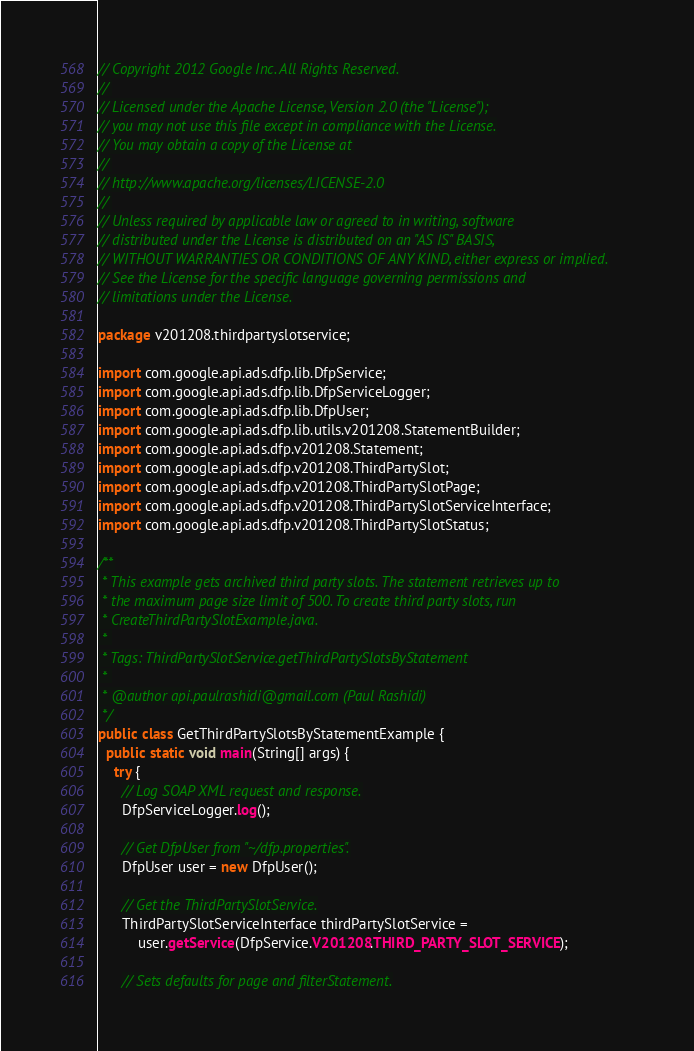<code> <loc_0><loc_0><loc_500><loc_500><_Java_>// Copyright 2012 Google Inc. All Rights Reserved.
//
// Licensed under the Apache License, Version 2.0 (the "License");
// you may not use this file except in compliance with the License.
// You may obtain a copy of the License at
//
// http://www.apache.org/licenses/LICENSE-2.0
//
// Unless required by applicable law or agreed to in writing, software
// distributed under the License is distributed on an "AS IS" BASIS,
// WITHOUT WARRANTIES OR CONDITIONS OF ANY KIND, either express or implied.
// See the License for the specific language governing permissions and
// limitations under the License.

package v201208.thirdpartyslotservice;

import com.google.api.ads.dfp.lib.DfpService;
import com.google.api.ads.dfp.lib.DfpServiceLogger;
import com.google.api.ads.dfp.lib.DfpUser;
import com.google.api.ads.dfp.lib.utils.v201208.StatementBuilder;
import com.google.api.ads.dfp.v201208.Statement;
import com.google.api.ads.dfp.v201208.ThirdPartySlot;
import com.google.api.ads.dfp.v201208.ThirdPartySlotPage;
import com.google.api.ads.dfp.v201208.ThirdPartySlotServiceInterface;
import com.google.api.ads.dfp.v201208.ThirdPartySlotStatus;

/**
 * This example gets archived third party slots. The statement retrieves up to
 * the maximum page size limit of 500. To create third party slots, run
 * CreateThirdPartySlotExample.java.
 * 
 * Tags: ThirdPartySlotService.getThirdPartySlotsByStatement
 * 
 * @author api.paulrashidi@gmail.com (Paul Rashidi)
 */
public class GetThirdPartySlotsByStatementExample {
  public static void main(String[] args) {
    try {
      // Log SOAP XML request and response.
      DfpServiceLogger.log();

      // Get DfpUser from "~/dfp.properties".
      DfpUser user = new DfpUser();

      // Get the ThirdPartySlotService.
      ThirdPartySlotServiceInterface thirdPartySlotService =
          user.getService(DfpService.V201208.THIRD_PARTY_SLOT_SERVICE);

      // Sets defaults for page and filterStatement.</code> 